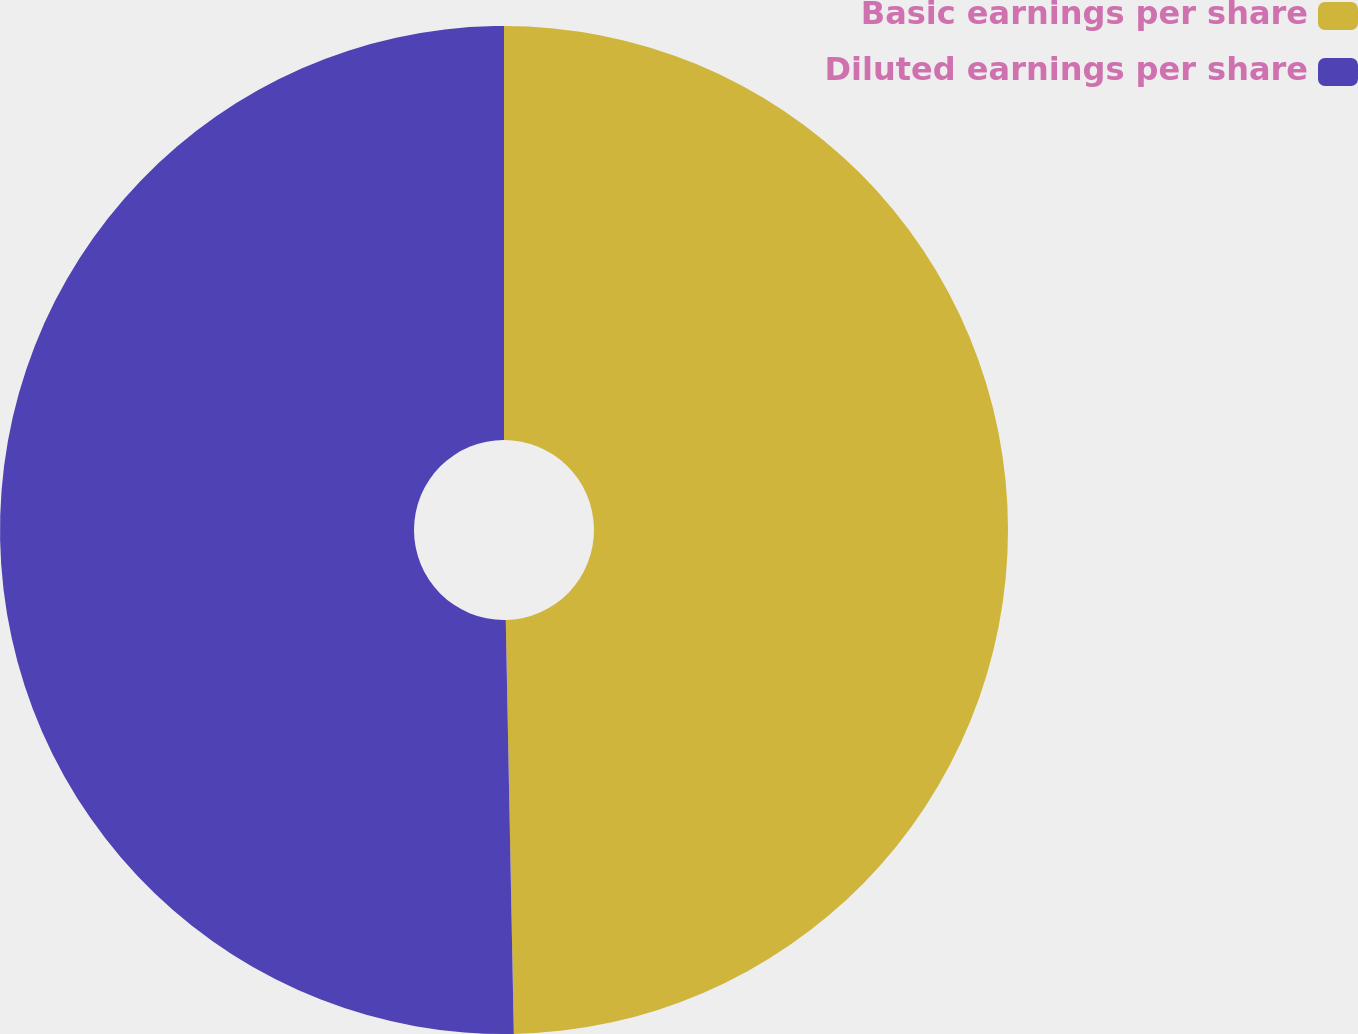Convert chart to OTSL. <chart><loc_0><loc_0><loc_500><loc_500><pie_chart><fcel>Basic earnings per share<fcel>Diluted earnings per share<nl><fcel>49.69%<fcel>50.31%<nl></chart> 